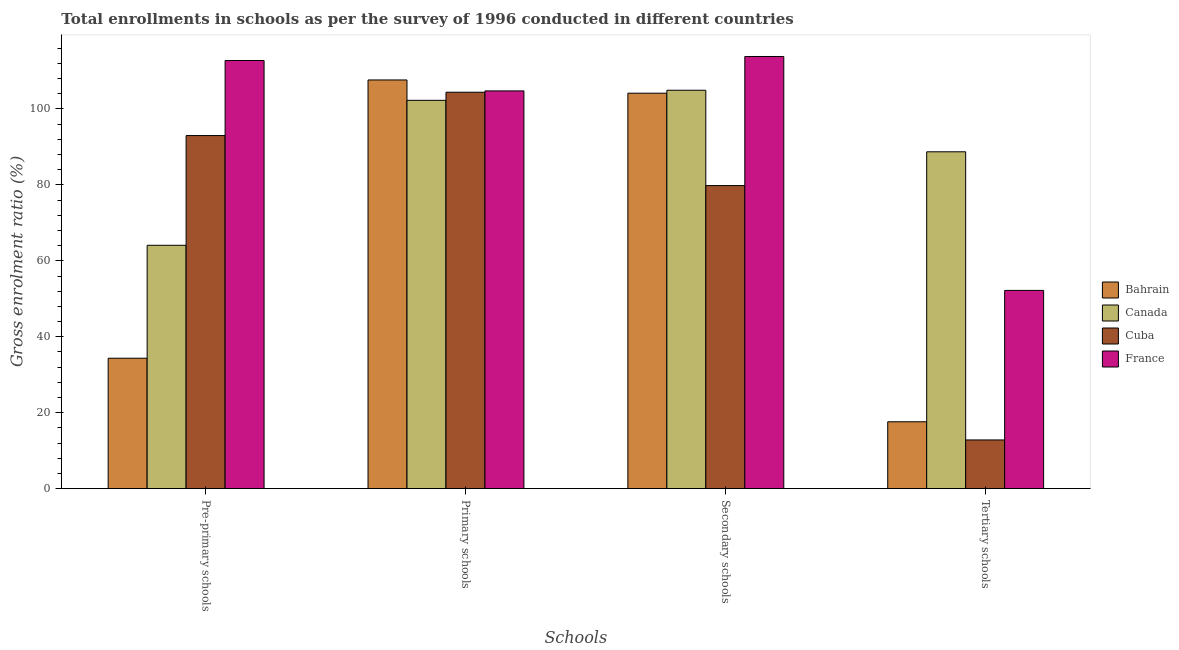How many different coloured bars are there?
Your answer should be very brief. 4. Are the number of bars on each tick of the X-axis equal?
Give a very brief answer. Yes. How many bars are there on the 2nd tick from the left?
Provide a succinct answer. 4. How many bars are there on the 1st tick from the right?
Provide a short and direct response. 4. What is the label of the 4th group of bars from the left?
Offer a terse response. Tertiary schools. What is the gross enrolment ratio in pre-primary schools in Canada?
Your answer should be very brief. 64.1. Across all countries, what is the maximum gross enrolment ratio in secondary schools?
Your answer should be very brief. 113.82. Across all countries, what is the minimum gross enrolment ratio in primary schools?
Keep it short and to the point. 102.27. In which country was the gross enrolment ratio in tertiary schools minimum?
Ensure brevity in your answer.  Cuba. What is the total gross enrolment ratio in tertiary schools in the graph?
Your response must be concise. 171.39. What is the difference between the gross enrolment ratio in tertiary schools in Canada and that in Bahrain?
Ensure brevity in your answer.  71.1. What is the difference between the gross enrolment ratio in secondary schools in Canada and the gross enrolment ratio in pre-primary schools in Cuba?
Ensure brevity in your answer.  11.93. What is the average gross enrolment ratio in tertiary schools per country?
Provide a succinct answer. 42.85. What is the difference between the gross enrolment ratio in primary schools and gross enrolment ratio in tertiary schools in Bahrain?
Your response must be concise. 90.02. What is the ratio of the gross enrolment ratio in tertiary schools in Cuba to that in Bahrain?
Offer a very short reply. 0.73. What is the difference between the highest and the second highest gross enrolment ratio in primary schools?
Ensure brevity in your answer.  2.88. What is the difference between the highest and the lowest gross enrolment ratio in tertiary schools?
Ensure brevity in your answer.  75.89. In how many countries, is the gross enrolment ratio in tertiary schools greater than the average gross enrolment ratio in tertiary schools taken over all countries?
Your answer should be compact. 2. Is the sum of the gross enrolment ratio in primary schools in France and Canada greater than the maximum gross enrolment ratio in tertiary schools across all countries?
Offer a very short reply. Yes. What does the 2nd bar from the left in Tertiary schools represents?
Make the answer very short. Canada. What does the 4th bar from the right in Secondary schools represents?
Ensure brevity in your answer.  Bahrain. How many bars are there?
Provide a short and direct response. 16. How many countries are there in the graph?
Offer a very short reply. 4. Are the values on the major ticks of Y-axis written in scientific E-notation?
Ensure brevity in your answer.  No. Does the graph contain grids?
Your response must be concise. No. How many legend labels are there?
Keep it short and to the point. 4. What is the title of the graph?
Provide a short and direct response. Total enrollments in schools as per the survey of 1996 conducted in different countries. What is the label or title of the X-axis?
Ensure brevity in your answer.  Schools. What is the label or title of the Y-axis?
Provide a short and direct response. Gross enrolment ratio (%). What is the Gross enrolment ratio (%) in Bahrain in Pre-primary schools?
Offer a very short reply. 34.35. What is the Gross enrolment ratio (%) of Canada in Pre-primary schools?
Provide a short and direct response. 64.1. What is the Gross enrolment ratio (%) of Cuba in Pre-primary schools?
Offer a very short reply. 93. What is the Gross enrolment ratio (%) in France in Pre-primary schools?
Keep it short and to the point. 112.77. What is the Gross enrolment ratio (%) in Bahrain in Primary schools?
Give a very brief answer. 107.64. What is the Gross enrolment ratio (%) in Canada in Primary schools?
Your answer should be very brief. 102.27. What is the Gross enrolment ratio (%) of Cuba in Primary schools?
Your answer should be very brief. 104.41. What is the Gross enrolment ratio (%) of France in Primary schools?
Provide a succinct answer. 104.76. What is the Gross enrolment ratio (%) of Bahrain in Secondary schools?
Make the answer very short. 104.16. What is the Gross enrolment ratio (%) in Canada in Secondary schools?
Provide a short and direct response. 104.93. What is the Gross enrolment ratio (%) in Cuba in Secondary schools?
Your answer should be very brief. 79.82. What is the Gross enrolment ratio (%) of France in Secondary schools?
Ensure brevity in your answer.  113.82. What is the Gross enrolment ratio (%) of Bahrain in Tertiary schools?
Ensure brevity in your answer.  17.62. What is the Gross enrolment ratio (%) in Canada in Tertiary schools?
Offer a very short reply. 88.72. What is the Gross enrolment ratio (%) of Cuba in Tertiary schools?
Keep it short and to the point. 12.83. What is the Gross enrolment ratio (%) in France in Tertiary schools?
Make the answer very short. 52.22. Across all Schools, what is the maximum Gross enrolment ratio (%) in Bahrain?
Your answer should be compact. 107.64. Across all Schools, what is the maximum Gross enrolment ratio (%) in Canada?
Ensure brevity in your answer.  104.93. Across all Schools, what is the maximum Gross enrolment ratio (%) of Cuba?
Offer a terse response. 104.41. Across all Schools, what is the maximum Gross enrolment ratio (%) of France?
Your response must be concise. 113.82. Across all Schools, what is the minimum Gross enrolment ratio (%) of Bahrain?
Provide a succinct answer. 17.62. Across all Schools, what is the minimum Gross enrolment ratio (%) in Canada?
Offer a terse response. 64.1. Across all Schools, what is the minimum Gross enrolment ratio (%) in Cuba?
Make the answer very short. 12.83. Across all Schools, what is the minimum Gross enrolment ratio (%) in France?
Provide a succinct answer. 52.22. What is the total Gross enrolment ratio (%) of Bahrain in the graph?
Provide a short and direct response. 263.77. What is the total Gross enrolment ratio (%) of Canada in the graph?
Offer a very short reply. 360.02. What is the total Gross enrolment ratio (%) in Cuba in the graph?
Offer a terse response. 290.06. What is the total Gross enrolment ratio (%) of France in the graph?
Keep it short and to the point. 383.56. What is the difference between the Gross enrolment ratio (%) in Bahrain in Pre-primary schools and that in Primary schools?
Provide a short and direct response. -73.28. What is the difference between the Gross enrolment ratio (%) of Canada in Pre-primary schools and that in Primary schools?
Your response must be concise. -38.17. What is the difference between the Gross enrolment ratio (%) of Cuba in Pre-primary schools and that in Primary schools?
Provide a succinct answer. -11.41. What is the difference between the Gross enrolment ratio (%) of France in Pre-primary schools and that in Primary schools?
Your answer should be very brief. 8.01. What is the difference between the Gross enrolment ratio (%) of Bahrain in Pre-primary schools and that in Secondary schools?
Provide a succinct answer. -69.8. What is the difference between the Gross enrolment ratio (%) in Canada in Pre-primary schools and that in Secondary schools?
Your answer should be compact. -40.83. What is the difference between the Gross enrolment ratio (%) in Cuba in Pre-primary schools and that in Secondary schools?
Provide a succinct answer. 13.17. What is the difference between the Gross enrolment ratio (%) of France in Pre-primary schools and that in Secondary schools?
Your response must be concise. -1.06. What is the difference between the Gross enrolment ratio (%) of Bahrain in Pre-primary schools and that in Tertiary schools?
Ensure brevity in your answer.  16.74. What is the difference between the Gross enrolment ratio (%) of Canada in Pre-primary schools and that in Tertiary schools?
Keep it short and to the point. -24.62. What is the difference between the Gross enrolment ratio (%) of Cuba in Pre-primary schools and that in Tertiary schools?
Give a very brief answer. 80.16. What is the difference between the Gross enrolment ratio (%) of France in Pre-primary schools and that in Tertiary schools?
Offer a terse response. 60.55. What is the difference between the Gross enrolment ratio (%) in Bahrain in Primary schools and that in Secondary schools?
Provide a short and direct response. 3.48. What is the difference between the Gross enrolment ratio (%) of Canada in Primary schools and that in Secondary schools?
Ensure brevity in your answer.  -2.66. What is the difference between the Gross enrolment ratio (%) of Cuba in Primary schools and that in Secondary schools?
Offer a very short reply. 24.58. What is the difference between the Gross enrolment ratio (%) in France in Primary schools and that in Secondary schools?
Give a very brief answer. -9.06. What is the difference between the Gross enrolment ratio (%) of Bahrain in Primary schools and that in Tertiary schools?
Ensure brevity in your answer.  90.02. What is the difference between the Gross enrolment ratio (%) in Canada in Primary schools and that in Tertiary schools?
Offer a terse response. 13.55. What is the difference between the Gross enrolment ratio (%) in Cuba in Primary schools and that in Tertiary schools?
Keep it short and to the point. 91.57. What is the difference between the Gross enrolment ratio (%) in France in Primary schools and that in Tertiary schools?
Provide a short and direct response. 52.54. What is the difference between the Gross enrolment ratio (%) in Bahrain in Secondary schools and that in Tertiary schools?
Your answer should be compact. 86.54. What is the difference between the Gross enrolment ratio (%) in Canada in Secondary schools and that in Tertiary schools?
Your answer should be compact. 16.21. What is the difference between the Gross enrolment ratio (%) of Cuba in Secondary schools and that in Tertiary schools?
Offer a terse response. 66.99. What is the difference between the Gross enrolment ratio (%) in France in Secondary schools and that in Tertiary schools?
Your answer should be very brief. 61.61. What is the difference between the Gross enrolment ratio (%) of Bahrain in Pre-primary schools and the Gross enrolment ratio (%) of Canada in Primary schools?
Provide a short and direct response. -67.92. What is the difference between the Gross enrolment ratio (%) in Bahrain in Pre-primary schools and the Gross enrolment ratio (%) in Cuba in Primary schools?
Provide a succinct answer. -70.05. What is the difference between the Gross enrolment ratio (%) in Bahrain in Pre-primary schools and the Gross enrolment ratio (%) in France in Primary schools?
Your answer should be very brief. -70.4. What is the difference between the Gross enrolment ratio (%) of Canada in Pre-primary schools and the Gross enrolment ratio (%) of Cuba in Primary schools?
Keep it short and to the point. -40.31. What is the difference between the Gross enrolment ratio (%) in Canada in Pre-primary schools and the Gross enrolment ratio (%) in France in Primary schools?
Provide a short and direct response. -40.66. What is the difference between the Gross enrolment ratio (%) of Cuba in Pre-primary schools and the Gross enrolment ratio (%) of France in Primary schools?
Offer a very short reply. -11.76. What is the difference between the Gross enrolment ratio (%) in Bahrain in Pre-primary schools and the Gross enrolment ratio (%) in Canada in Secondary schools?
Keep it short and to the point. -70.57. What is the difference between the Gross enrolment ratio (%) in Bahrain in Pre-primary schools and the Gross enrolment ratio (%) in Cuba in Secondary schools?
Keep it short and to the point. -45.47. What is the difference between the Gross enrolment ratio (%) in Bahrain in Pre-primary schools and the Gross enrolment ratio (%) in France in Secondary schools?
Offer a terse response. -79.47. What is the difference between the Gross enrolment ratio (%) of Canada in Pre-primary schools and the Gross enrolment ratio (%) of Cuba in Secondary schools?
Ensure brevity in your answer.  -15.72. What is the difference between the Gross enrolment ratio (%) of Canada in Pre-primary schools and the Gross enrolment ratio (%) of France in Secondary schools?
Your answer should be compact. -49.72. What is the difference between the Gross enrolment ratio (%) of Cuba in Pre-primary schools and the Gross enrolment ratio (%) of France in Secondary schools?
Your response must be concise. -20.83. What is the difference between the Gross enrolment ratio (%) in Bahrain in Pre-primary schools and the Gross enrolment ratio (%) in Canada in Tertiary schools?
Keep it short and to the point. -54.37. What is the difference between the Gross enrolment ratio (%) of Bahrain in Pre-primary schools and the Gross enrolment ratio (%) of Cuba in Tertiary schools?
Keep it short and to the point. 21.52. What is the difference between the Gross enrolment ratio (%) of Bahrain in Pre-primary schools and the Gross enrolment ratio (%) of France in Tertiary schools?
Make the answer very short. -17.86. What is the difference between the Gross enrolment ratio (%) of Canada in Pre-primary schools and the Gross enrolment ratio (%) of Cuba in Tertiary schools?
Offer a terse response. 51.27. What is the difference between the Gross enrolment ratio (%) of Canada in Pre-primary schools and the Gross enrolment ratio (%) of France in Tertiary schools?
Provide a succinct answer. 11.88. What is the difference between the Gross enrolment ratio (%) of Cuba in Pre-primary schools and the Gross enrolment ratio (%) of France in Tertiary schools?
Ensure brevity in your answer.  40.78. What is the difference between the Gross enrolment ratio (%) in Bahrain in Primary schools and the Gross enrolment ratio (%) in Canada in Secondary schools?
Your response must be concise. 2.71. What is the difference between the Gross enrolment ratio (%) in Bahrain in Primary schools and the Gross enrolment ratio (%) in Cuba in Secondary schools?
Keep it short and to the point. 27.82. What is the difference between the Gross enrolment ratio (%) in Bahrain in Primary schools and the Gross enrolment ratio (%) in France in Secondary schools?
Offer a terse response. -6.18. What is the difference between the Gross enrolment ratio (%) of Canada in Primary schools and the Gross enrolment ratio (%) of Cuba in Secondary schools?
Offer a terse response. 22.45. What is the difference between the Gross enrolment ratio (%) in Canada in Primary schools and the Gross enrolment ratio (%) in France in Secondary schools?
Your answer should be compact. -11.55. What is the difference between the Gross enrolment ratio (%) of Cuba in Primary schools and the Gross enrolment ratio (%) of France in Secondary schools?
Offer a very short reply. -9.41. What is the difference between the Gross enrolment ratio (%) in Bahrain in Primary schools and the Gross enrolment ratio (%) in Canada in Tertiary schools?
Ensure brevity in your answer.  18.92. What is the difference between the Gross enrolment ratio (%) of Bahrain in Primary schools and the Gross enrolment ratio (%) of Cuba in Tertiary schools?
Ensure brevity in your answer.  94.81. What is the difference between the Gross enrolment ratio (%) of Bahrain in Primary schools and the Gross enrolment ratio (%) of France in Tertiary schools?
Your answer should be very brief. 55.42. What is the difference between the Gross enrolment ratio (%) in Canada in Primary schools and the Gross enrolment ratio (%) in Cuba in Tertiary schools?
Make the answer very short. 89.44. What is the difference between the Gross enrolment ratio (%) of Canada in Primary schools and the Gross enrolment ratio (%) of France in Tertiary schools?
Your answer should be compact. 50.06. What is the difference between the Gross enrolment ratio (%) of Cuba in Primary schools and the Gross enrolment ratio (%) of France in Tertiary schools?
Your answer should be compact. 52.19. What is the difference between the Gross enrolment ratio (%) in Bahrain in Secondary schools and the Gross enrolment ratio (%) in Canada in Tertiary schools?
Give a very brief answer. 15.43. What is the difference between the Gross enrolment ratio (%) in Bahrain in Secondary schools and the Gross enrolment ratio (%) in Cuba in Tertiary schools?
Offer a terse response. 91.32. What is the difference between the Gross enrolment ratio (%) of Bahrain in Secondary schools and the Gross enrolment ratio (%) of France in Tertiary schools?
Offer a very short reply. 51.94. What is the difference between the Gross enrolment ratio (%) of Canada in Secondary schools and the Gross enrolment ratio (%) of Cuba in Tertiary schools?
Ensure brevity in your answer.  92.1. What is the difference between the Gross enrolment ratio (%) of Canada in Secondary schools and the Gross enrolment ratio (%) of France in Tertiary schools?
Ensure brevity in your answer.  52.71. What is the difference between the Gross enrolment ratio (%) in Cuba in Secondary schools and the Gross enrolment ratio (%) in France in Tertiary schools?
Your answer should be compact. 27.61. What is the average Gross enrolment ratio (%) in Bahrain per Schools?
Make the answer very short. 65.94. What is the average Gross enrolment ratio (%) of Canada per Schools?
Your response must be concise. 90. What is the average Gross enrolment ratio (%) of Cuba per Schools?
Your answer should be very brief. 72.51. What is the average Gross enrolment ratio (%) of France per Schools?
Keep it short and to the point. 95.89. What is the difference between the Gross enrolment ratio (%) in Bahrain and Gross enrolment ratio (%) in Canada in Pre-primary schools?
Provide a short and direct response. -29.74. What is the difference between the Gross enrolment ratio (%) in Bahrain and Gross enrolment ratio (%) in Cuba in Pre-primary schools?
Provide a short and direct response. -58.64. What is the difference between the Gross enrolment ratio (%) of Bahrain and Gross enrolment ratio (%) of France in Pre-primary schools?
Give a very brief answer. -78.41. What is the difference between the Gross enrolment ratio (%) of Canada and Gross enrolment ratio (%) of Cuba in Pre-primary schools?
Your response must be concise. -28.9. What is the difference between the Gross enrolment ratio (%) of Canada and Gross enrolment ratio (%) of France in Pre-primary schools?
Keep it short and to the point. -48.67. What is the difference between the Gross enrolment ratio (%) of Cuba and Gross enrolment ratio (%) of France in Pre-primary schools?
Your answer should be very brief. -19.77. What is the difference between the Gross enrolment ratio (%) in Bahrain and Gross enrolment ratio (%) in Canada in Primary schools?
Provide a short and direct response. 5.37. What is the difference between the Gross enrolment ratio (%) in Bahrain and Gross enrolment ratio (%) in Cuba in Primary schools?
Give a very brief answer. 3.23. What is the difference between the Gross enrolment ratio (%) of Bahrain and Gross enrolment ratio (%) of France in Primary schools?
Give a very brief answer. 2.88. What is the difference between the Gross enrolment ratio (%) of Canada and Gross enrolment ratio (%) of Cuba in Primary schools?
Provide a short and direct response. -2.14. What is the difference between the Gross enrolment ratio (%) of Canada and Gross enrolment ratio (%) of France in Primary schools?
Your answer should be compact. -2.49. What is the difference between the Gross enrolment ratio (%) of Cuba and Gross enrolment ratio (%) of France in Primary schools?
Ensure brevity in your answer.  -0.35. What is the difference between the Gross enrolment ratio (%) in Bahrain and Gross enrolment ratio (%) in Canada in Secondary schools?
Offer a very short reply. -0.77. What is the difference between the Gross enrolment ratio (%) of Bahrain and Gross enrolment ratio (%) of Cuba in Secondary schools?
Make the answer very short. 24.33. What is the difference between the Gross enrolment ratio (%) in Bahrain and Gross enrolment ratio (%) in France in Secondary schools?
Offer a very short reply. -9.67. What is the difference between the Gross enrolment ratio (%) in Canada and Gross enrolment ratio (%) in Cuba in Secondary schools?
Give a very brief answer. 25.11. What is the difference between the Gross enrolment ratio (%) in Canada and Gross enrolment ratio (%) in France in Secondary schools?
Keep it short and to the point. -8.89. What is the difference between the Gross enrolment ratio (%) of Cuba and Gross enrolment ratio (%) of France in Secondary schools?
Make the answer very short. -34. What is the difference between the Gross enrolment ratio (%) of Bahrain and Gross enrolment ratio (%) of Canada in Tertiary schools?
Your answer should be compact. -71.1. What is the difference between the Gross enrolment ratio (%) in Bahrain and Gross enrolment ratio (%) in Cuba in Tertiary schools?
Offer a terse response. 4.79. What is the difference between the Gross enrolment ratio (%) in Bahrain and Gross enrolment ratio (%) in France in Tertiary schools?
Provide a succinct answer. -34.6. What is the difference between the Gross enrolment ratio (%) of Canada and Gross enrolment ratio (%) of Cuba in Tertiary schools?
Offer a very short reply. 75.89. What is the difference between the Gross enrolment ratio (%) in Canada and Gross enrolment ratio (%) in France in Tertiary schools?
Make the answer very short. 36.51. What is the difference between the Gross enrolment ratio (%) of Cuba and Gross enrolment ratio (%) of France in Tertiary schools?
Offer a very short reply. -39.38. What is the ratio of the Gross enrolment ratio (%) of Bahrain in Pre-primary schools to that in Primary schools?
Your answer should be very brief. 0.32. What is the ratio of the Gross enrolment ratio (%) of Canada in Pre-primary schools to that in Primary schools?
Your answer should be very brief. 0.63. What is the ratio of the Gross enrolment ratio (%) of Cuba in Pre-primary schools to that in Primary schools?
Your answer should be compact. 0.89. What is the ratio of the Gross enrolment ratio (%) of France in Pre-primary schools to that in Primary schools?
Give a very brief answer. 1.08. What is the ratio of the Gross enrolment ratio (%) in Bahrain in Pre-primary schools to that in Secondary schools?
Give a very brief answer. 0.33. What is the ratio of the Gross enrolment ratio (%) in Canada in Pre-primary schools to that in Secondary schools?
Provide a short and direct response. 0.61. What is the ratio of the Gross enrolment ratio (%) of Cuba in Pre-primary schools to that in Secondary schools?
Offer a very short reply. 1.17. What is the ratio of the Gross enrolment ratio (%) in France in Pre-primary schools to that in Secondary schools?
Keep it short and to the point. 0.99. What is the ratio of the Gross enrolment ratio (%) in Bahrain in Pre-primary schools to that in Tertiary schools?
Provide a succinct answer. 1.95. What is the ratio of the Gross enrolment ratio (%) in Canada in Pre-primary schools to that in Tertiary schools?
Give a very brief answer. 0.72. What is the ratio of the Gross enrolment ratio (%) in Cuba in Pre-primary schools to that in Tertiary schools?
Your answer should be compact. 7.25. What is the ratio of the Gross enrolment ratio (%) of France in Pre-primary schools to that in Tertiary schools?
Give a very brief answer. 2.16. What is the ratio of the Gross enrolment ratio (%) of Bahrain in Primary schools to that in Secondary schools?
Offer a very short reply. 1.03. What is the ratio of the Gross enrolment ratio (%) in Canada in Primary schools to that in Secondary schools?
Offer a very short reply. 0.97. What is the ratio of the Gross enrolment ratio (%) of Cuba in Primary schools to that in Secondary schools?
Keep it short and to the point. 1.31. What is the ratio of the Gross enrolment ratio (%) of France in Primary schools to that in Secondary schools?
Keep it short and to the point. 0.92. What is the ratio of the Gross enrolment ratio (%) in Bahrain in Primary schools to that in Tertiary schools?
Your answer should be compact. 6.11. What is the ratio of the Gross enrolment ratio (%) in Canada in Primary schools to that in Tertiary schools?
Your response must be concise. 1.15. What is the ratio of the Gross enrolment ratio (%) of Cuba in Primary schools to that in Tertiary schools?
Your answer should be compact. 8.14. What is the ratio of the Gross enrolment ratio (%) of France in Primary schools to that in Tertiary schools?
Keep it short and to the point. 2.01. What is the ratio of the Gross enrolment ratio (%) in Bahrain in Secondary schools to that in Tertiary schools?
Provide a short and direct response. 5.91. What is the ratio of the Gross enrolment ratio (%) in Canada in Secondary schools to that in Tertiary schools?
Offer a terse response. 1.18. What is the ratio of the Gross enrolment ratio (%) of Cuba in Secondary schools to that in Tertiary schools?
Your answer should be very brief. 6.22. What is the ratio of the Gross enrolment ratio (%) of France in Secondary schools to that in Tertiary schools?
Your answer should be very brief. 2.18. What is the difference between the highest and the second highest Gross enrolment ratio (%) in Bahrain?
Your answer should be very brief. 3.48. What is the difference between the highest and the second highest Gross enrolment ratio (%) of Canada?
Your answer should be compact. 2.66. What is the difference between the highest and the second highest Gross enrolment ratio (%) in Cuba?
Keep it short and to the point. 11.41. What is the difference between the highest and the second highest Gross enrolment ratio (%) in France?
Your response must be concise. 1.06. What is the difference between the highest and the lowest Gross enrolment ratio (%) of Bahrain?
Keep it short and to the point. 90.02. What is the difference between the highest and the lowest Gross enrolment ratio (%) in Canada?
Keep it short and to the point. 40.83. What is the difference between the highest and the lowest Gross enrolment ratio (%) in Cuba?
Your response must be concise. 91.57. What is the difference between the highest and the lowest Gross enrolment ratio (%) in France?
Give a very brief answer. 61.61. 